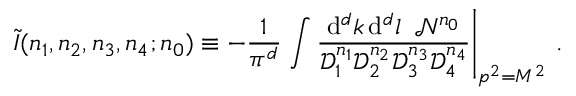<formula> <loc_0><loc_0><loc_500><loc_500>\widetilde { I } ( n _ { 1 } , n _ { 2 } , n _ { 3 } , n _ { 4 } ; n _ { 0 } ) \equiv - \frac { 1 } { \pi ^ { d } } \int \frac { d ^ { d } k \, d ^ { d } l \, \mathcal { N } ^ { n _ { 0 } } } { \mathcal { D } _ { 1 } ^ { n _ { 1 } } \mathcal { D } _ { 2 } ^ { n _ { 2 } } \mathcal { D } _ { 3 } ^ { n _ { 3 } } \mathcal { D } _ { 4 } ^ { n _ { 4 } } } \right | _ { p ^ { 2 } = M ^ { 2 } } \, .</formula> 